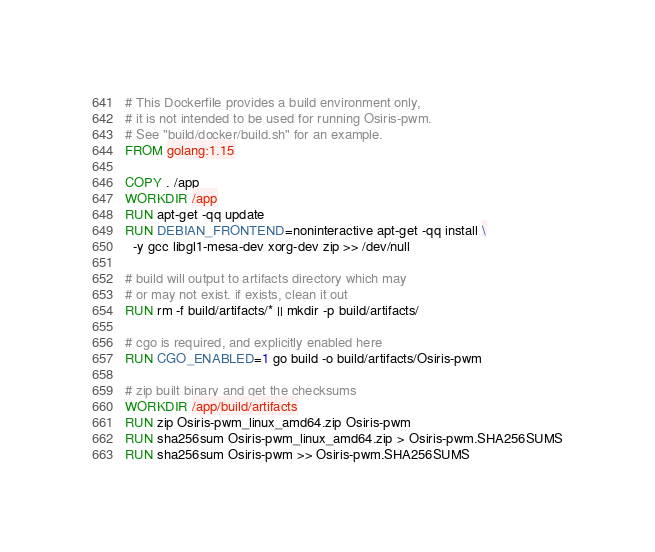Convert code to text. <code><loc_0><loc_0><loc_500><loc_500><_Dockerfile_># This Dockerfile provides a build environment only,
# it is not intended to be used for running Osiris-pwm.
# See "build/docker/build.sh" for an example.
FROM golang:1.15

COPY . /app
WORKDIR /app
RUN apt-get -qq update
RUN DEBIAN_FRONTEND=noninteractive apt-get -qq install \
  -y gcc libgl1-mesa-dev xorg-dev zip >> /dev/null

# build will output to artifacts directory which may
# or may not exist. if exists, clean it out
RUN rm -f build/artifacts/* || mkdir -p build/artifacts/

# cgo is required, and explicitly enabled here
RUN CGO_ENABLED=1 go build -o build/artifacts/Osiris-pwm

# zip built binary and get the checksums
WORKDIR /app/build/artifacts
RUN zip Osiris-pwm_linux_amd64.zip Osiris-pwm
RUN sha256sum Osiris-pwm_linux_amd64.zip > Osiris-pwm.SHA256SUMS
RUN sha256sum Osiris-pwm >> Osiris-pwm.SHA256SUMS
</code> 